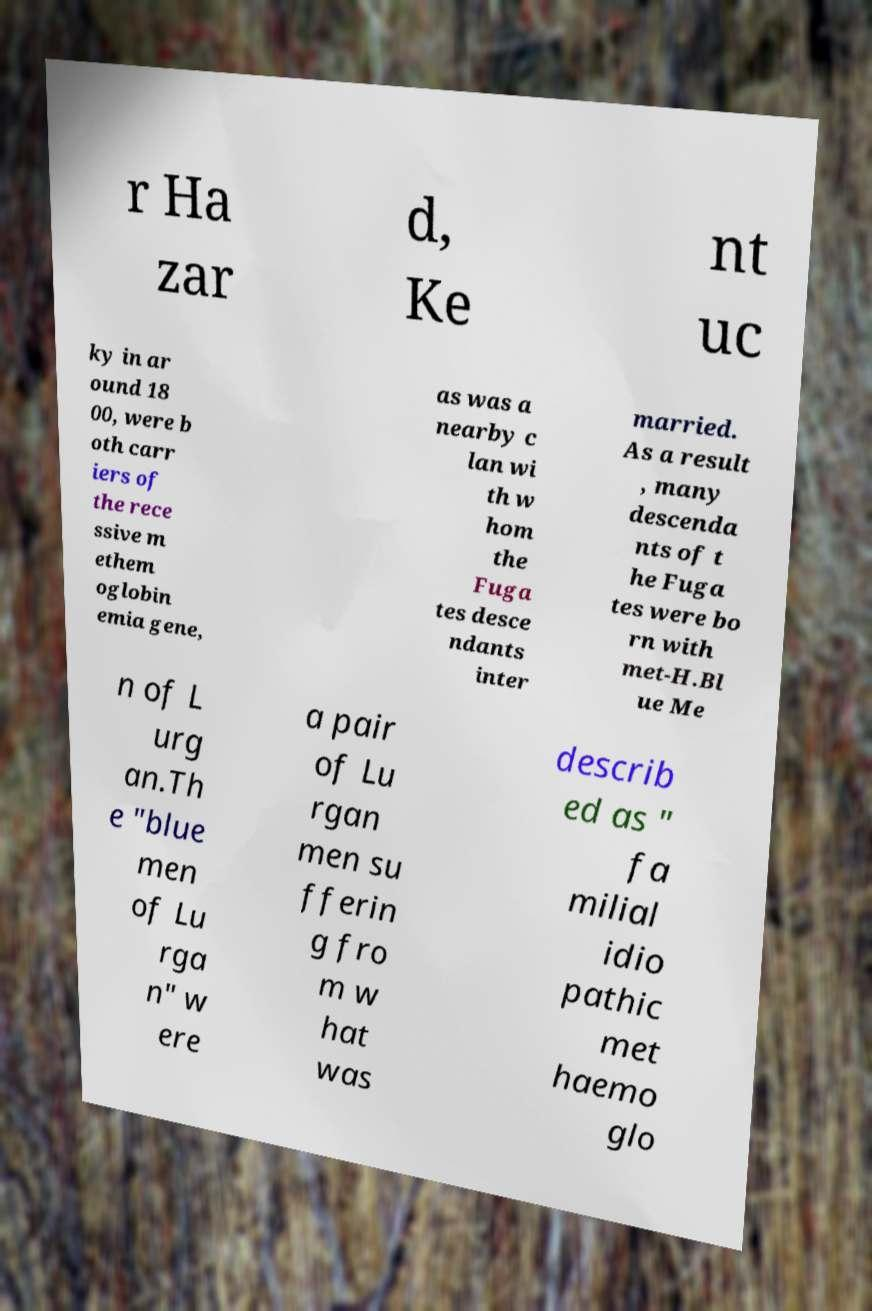Could you extract and type out the text from this image? r Ha zar d, Ke nt uc ky in ar ound 18 00, were b oth carr iers of the rece ssive m ethem oglobin emia gene, as was a nearby c lan wi th w hom the Fuga tes desce ndants inter married. As a result , many descenda nts of t he Fuga tes were bo rn with met-H.Bl ue Me n of L urg an.Th e "blue men of Lu rga n" w ere a pair of Lu rgan men su fferin g fro m w hat was describ ed as " fa milial idio pathic met haemo glo 